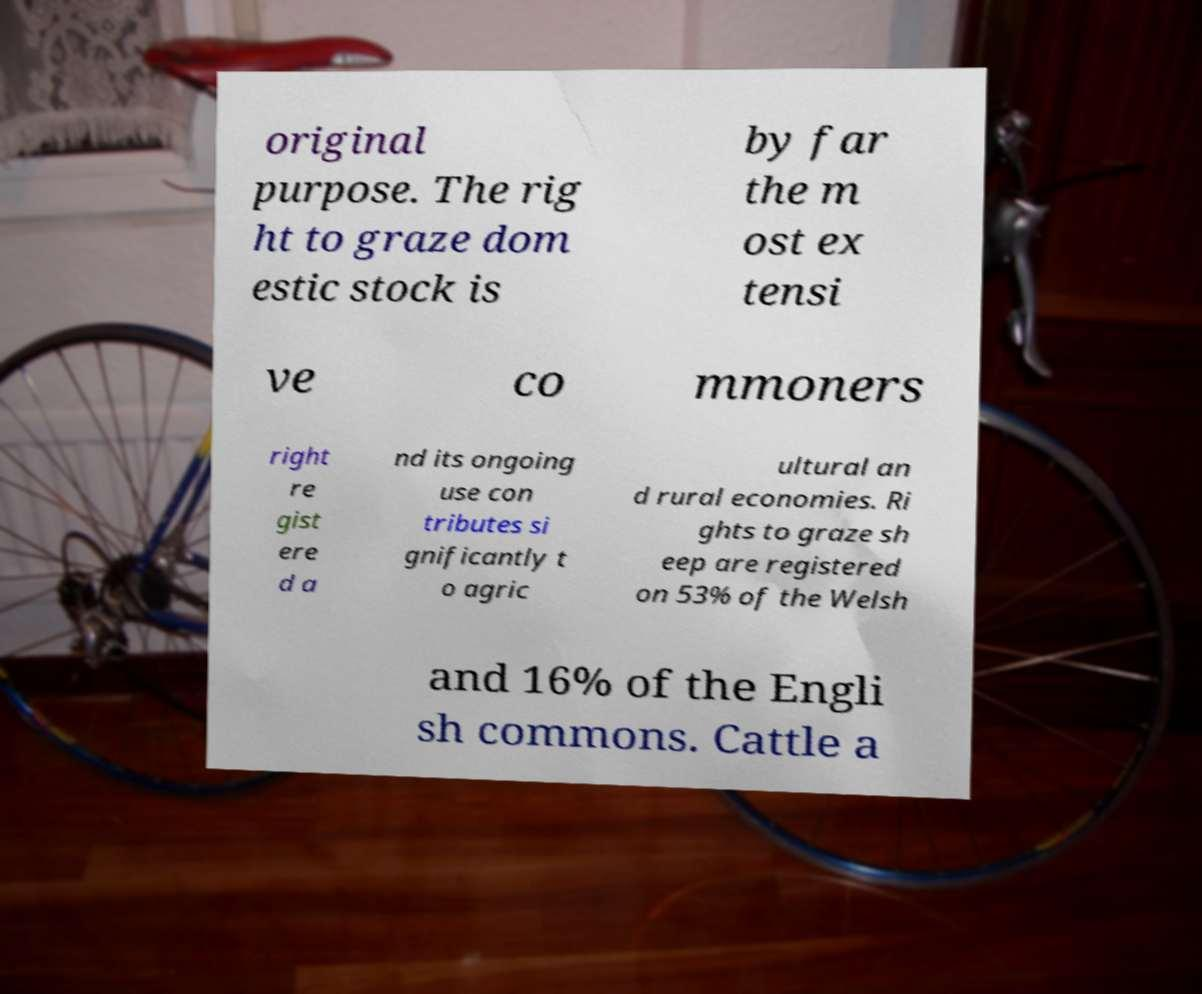What messages or text are displayed in this image? I need them in a readable, typed format. original purpose. The rig ht to graze dom estic stock is by far the m ost ex tensi ve co mmoners right re gist ere d a nd its ongoing use con tributes si gnificantly t o agric ultural an d rural economies. Ri ghts to graze sh eep are registered on 53% of the Welsh and 16% of the Engli sh commons. Cattle a 